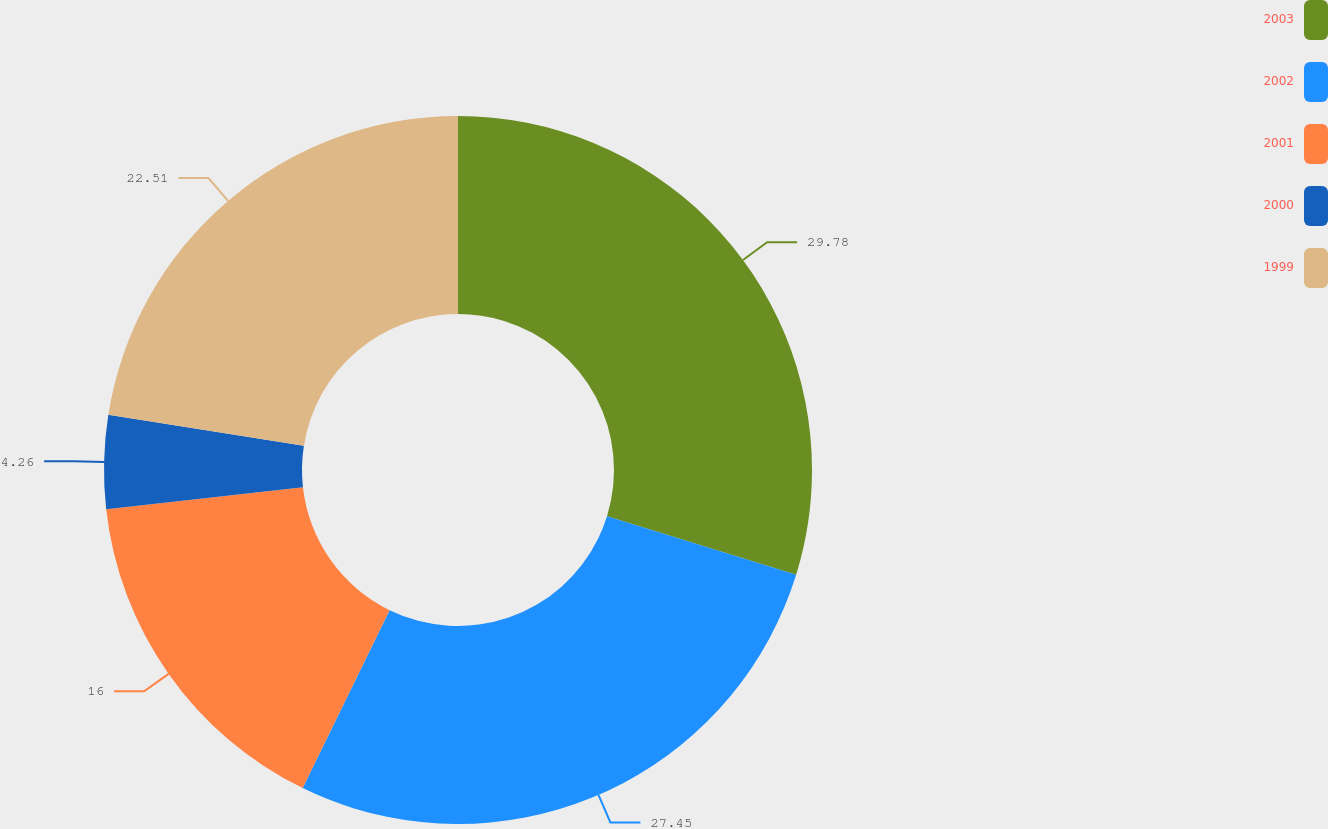Convert chart. <chart><loc_0><loc_0><loc_500><loc_500><pie_chart><fcel>2003<fcel>2002<fcel>2001<fcel>2000<fcel>1999<nl><fcel>29.78%<fcel>27.45%<fcel>16.0%<fcel>4.26%<fcel>22.51%<nl></chart> 